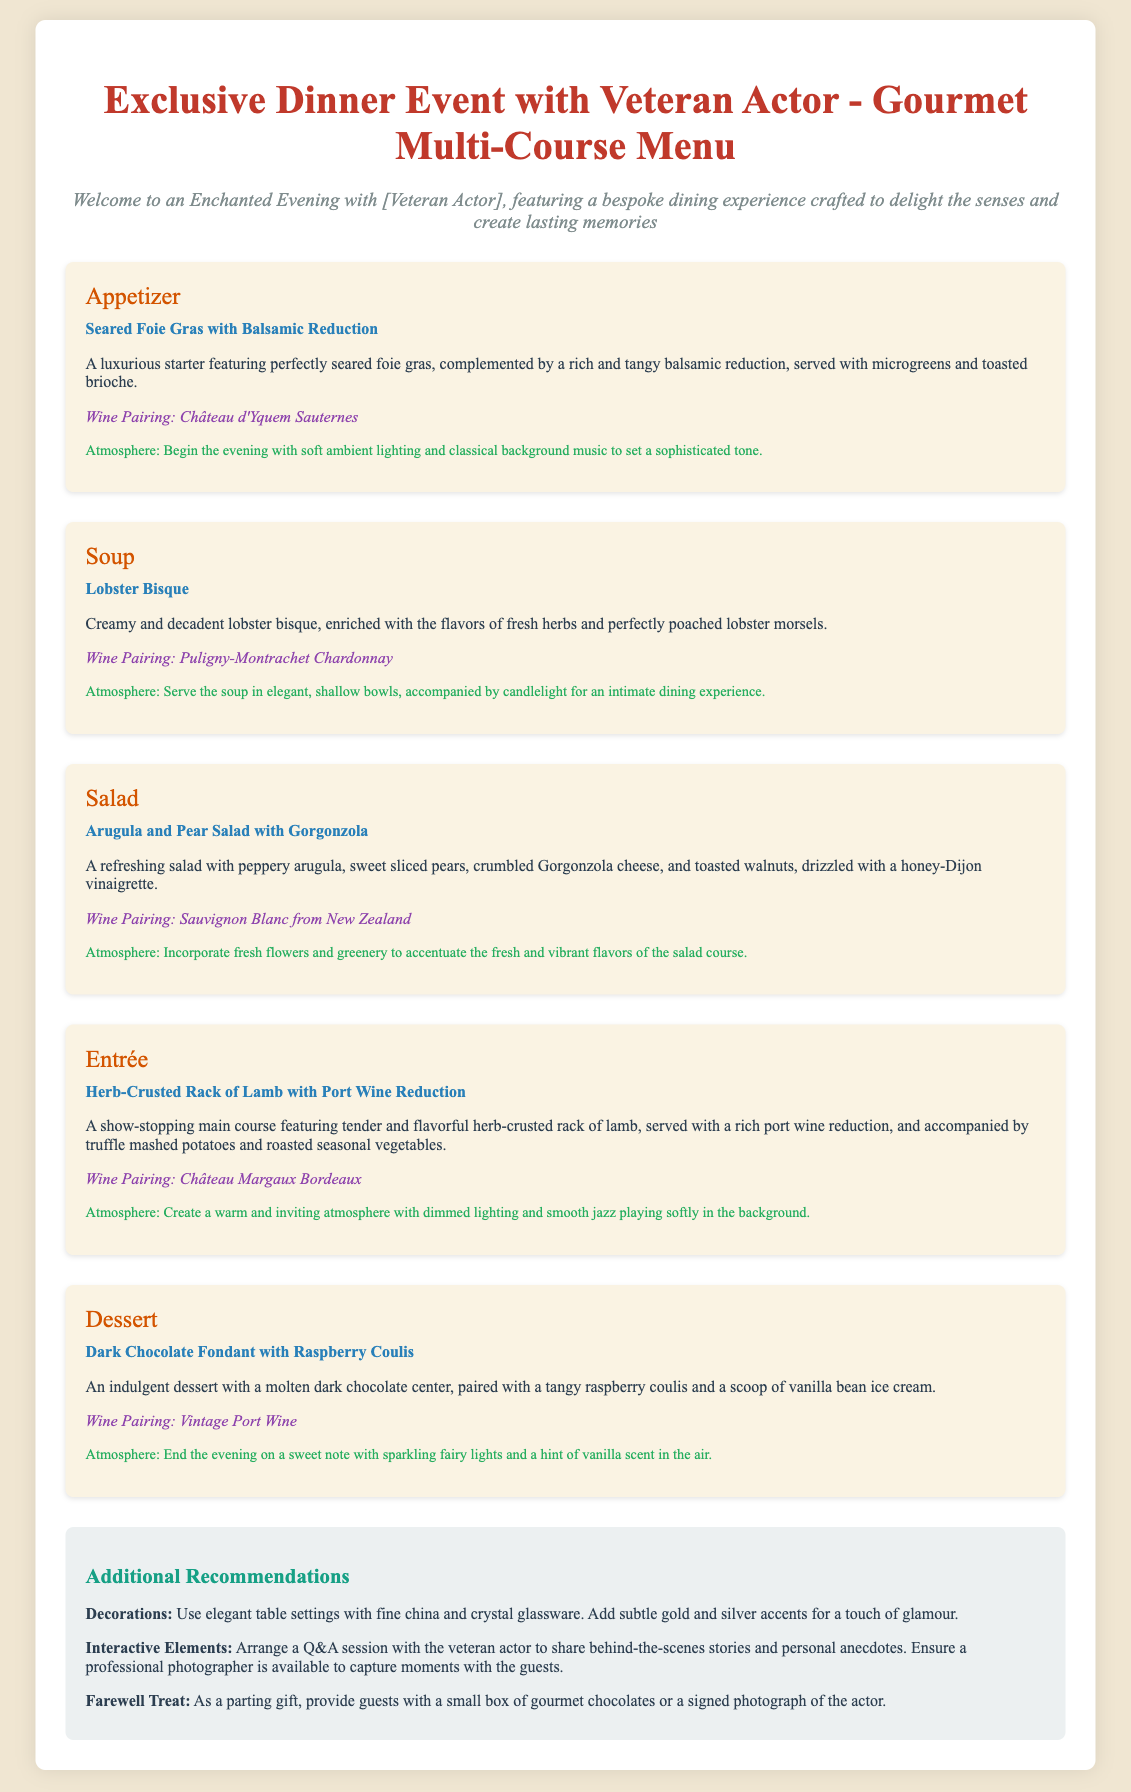What is the name of the main course? The main course is identified as the Entrée in the document, which features a Herb-Crusted Rack of Lamb.
Answer: Herb-Crusted Rack of Lamb What is the wine pairing for the dessert? The dessert section specifies a wine pairing to enhance the flavors of the Dark Chocolate Fondant with Raspberry Coulis.
Answer: Vintage Port Wine How many courses are included in the gourmet menu? The document outlines five distinct courses, indicating the detailed structure of the meal plan.
Answer: Five What atmosphere is recommended for the appetizer course? The atmosphere section for the appetizer provides specific suggestions to create a suitable environment for the dining experience.
Answer: Soft ambient lighting and classical background music What is a suggested farewell treat for guests? The document mentions a farewell treat that would be given to guests as a parting gift at the end of the event.
Answer: A small box of gourmet chocolates Which dish is served as the soup course? The document specifies the soup course as Lobster Bisque, highlighting it in the menu.
Answer: Lobster Bisque What is the recommended decoration style for the dinner tables? The additional recommendations section discusses the decorative aspects, suggesting a specific style of table settings for elegance.
Answer: Elegant table settings with fine china and crystal glassware What additional element is suggested to engage guests during the event? The interactive elements section discusses ways to involve guests and enhance their experience during the event.
Answer: Arrange a Q&A session with the veteran actor 